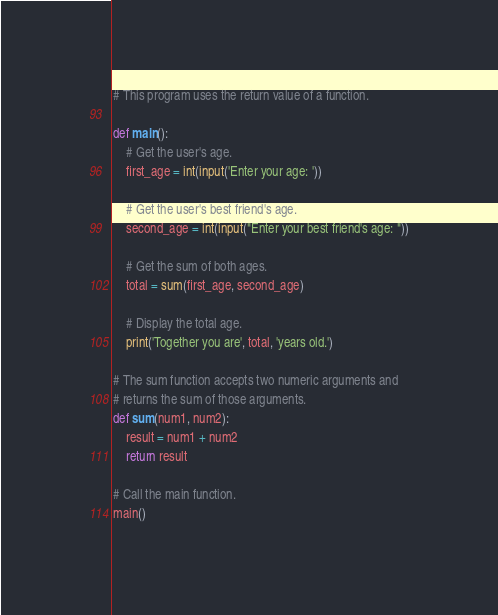<code> <loc_0><loc_0><loc_500><loc_500><_Python_># This program uses the return value of a function.

def main():
    # Get the user's age.
    first_age = int(input('Enter your age: '))

    # Get the user's best friend's age.
    second_age = int(input("Enter your best friend's age: "))

    # Get the sum of both ages.
    total = sum(first_age, second_age)

    # Display the total age.
    print('Together you are', total, 'years old.')

# The sum function accepts two numeric arguments and
# returns the sum of those arguments.
def sum(num1, num2):
    result = num1 + num2
    return result

# Call the main function.
main()
</code> 